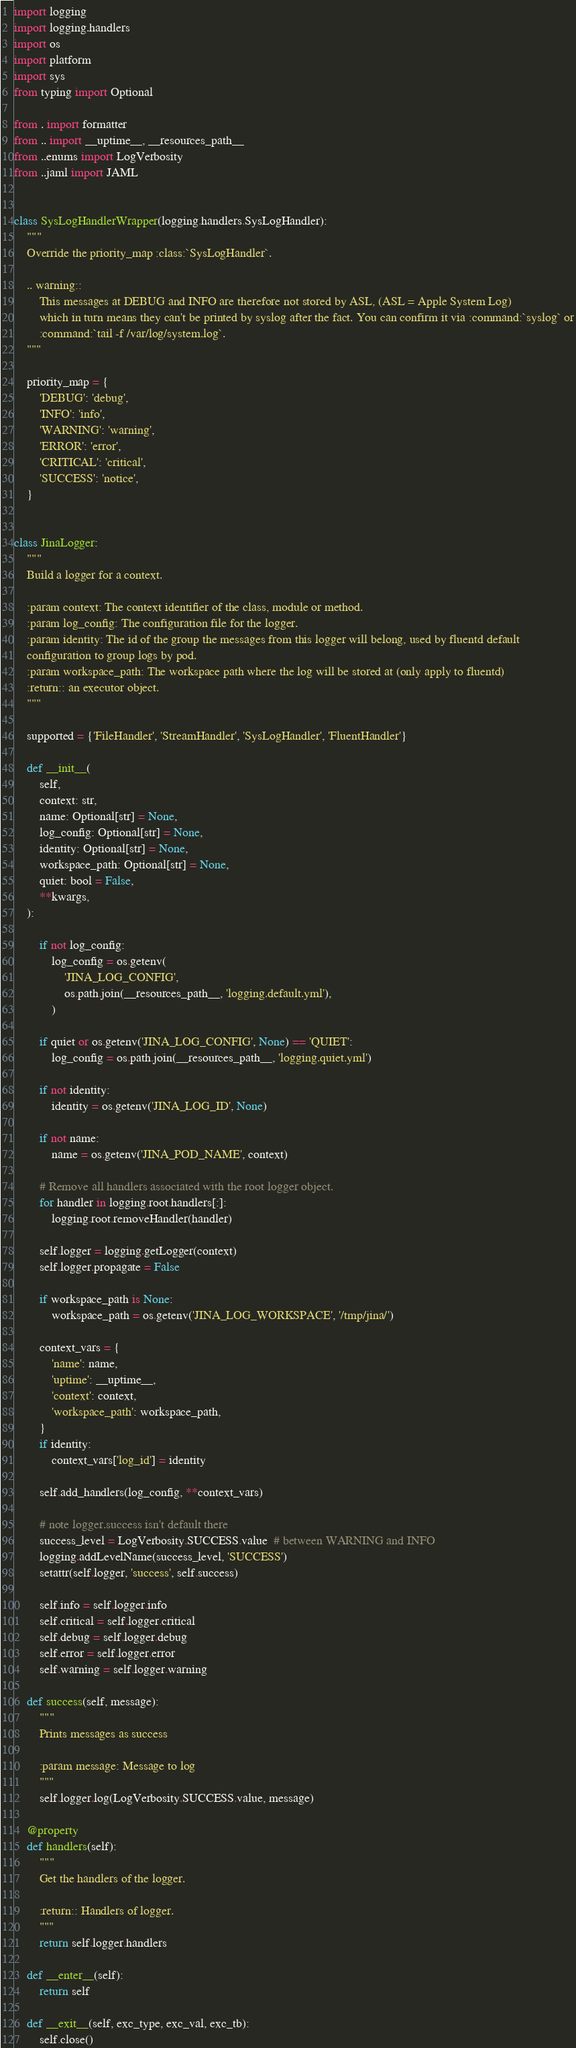Convert code to text. <code><loc_0><loc_0><loc_500><loc_500><_Python_>import logging
import logging.handlers
import os
import platform
import sys
from typing import Optional

from . import formatter
from .. import __uptime__, __resources_path__
from ..enums import LogVerbosity
from ..jaml import JAML


class SysLogHandlerWrapper(logging.handlers.SysLogHandler):
    """
    Override the priority_map :class:`SysLogHandler`.

    .. warning::
        This messages at DEBUG and INFO are therefore not stored by ASL, (ASL = Apple System Log)
        which in turn means they can't be printed by syslog after the fact. You can confirm it via :command:`syslog` or
        :command:`tail -f /var/log/system.log`.
    """

    priority_map = {
        'DEBUG': 'debug',
        'INFO': 'info',
        'WARNING': 'warning',
        'ERROR': 'error',
        'CRITICAL': 'critical',
        'SUCCESS': 'notice',
    }


class JinaLogger:
    """
    Build a logger for a context.

    :param context: The context identifier of the class, module or method.
    :param log_config: The configuration file for the logger.
    :param identity: The id of the group the messages from this logger will belong, used by fluentd default
    configuration to group logs by pod.
    :param workspace_path: The workspace path where the log will be stored at (only apply to fluentd)
    :return:: an executor object.
    """

    supported = {'FileHandler', 'StreamHandler', 'SysLogHandler', 'FluentHandler'}

    def __init__(
        self,
        context: str,
        name: Optional[str] = None,
        log_config: Optional[str] = None,
        identity: Optional[str] = None,
        workspace_path: Optional[str] = None,
        quiet: bool = False,
        **kwargs,
    ):

        if not log_config:
            log_config = os.getenv(
                'JINA_LOG_CONFIG',
                os.path.join(__resources_path__, 'logging.default.yml'),
            )

        if quiet or os.getenv('JINA_LOG_CONFIG', None) == 'QUIET':
            log_config = os.path.join(__resources_path__, 'logging.quiet.yml')

        if not identity:
            identity = os.getenv('JINA_LOG_ID', None)

        if not name:
            name = os.getenv('JINA_POD_NAME', context)

        # Remove all handlers associated with the root logger object.
        for handler in logging.root.handlers[:]:
            logging.root.removeHandler(handler)

        self.logger = logging.getLogger(context)
        self.logger.propagate = False

        if workspace_path is None:
            workspace_path = os.getenv('JINA_LOG_WORKSPACE', '/tmp/jina/')

        context_vars = {
            'name': name,
            'uptime': __uptime__,
            'context': context,
            'workspace_path': workspace_path,
        }
        if identity:
            context_vars['log_id'] = identity

        self.add_handlers(log_config, **context_vars)

        # note logger.success isn't default there
        success_level = LogVerbosity.SUCCESS.value  # between WARNING and INFO
        logging.addLevelName(success_level, 'SUCCESS')
        setattr(self.logger, 'success', self.success)

        self.info = self.logger.info
        self.critical = self.logger.critical
        self.debug = self.logger.debug
        self.error = self.logger.error
        self.warning = self.logger.warning

    def success(self, message):
        """
        Prints messages as success

        :param message: Message to log
        """
        self.logger.log(LogVerbosity.SUCCESS.value, message)

    @property
    def handlers(self):
        """
        Get the handlers of the logger.

        :return:: Handlers of logger.
        """
        return self.logger.handlers

    def __enter__(self):
        return self

    def __exit__(self, exc_type, exc_val, exc_tb):
        self.close()
</code> 